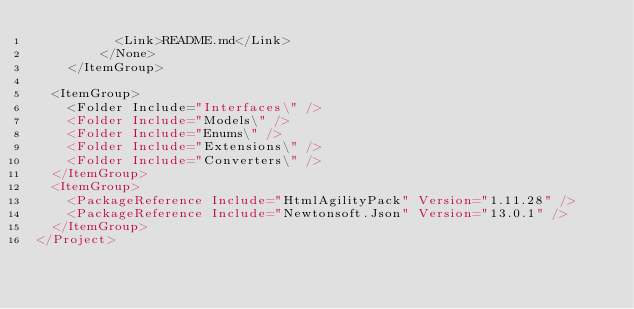<code> <loc_0><loc_0><loc_500><loc_500><_XML_>          <Link>README.md</Link>
        </None>
    </ItemGroup>
  
  <ItemGroup>
    <Folder Include="Interfaces\" />
    <Folder Include="Models\" />
    <Folder Include="Enums\" />
    <Folder Include="Extensions\" />
    <Folder Include="Converters\" />
  </ItemGroup>
  <ItemGroup>
    <PackageReference Include="HtmlAgilityPack" Version="1.11.28" />
    <PackageReference Include="Newtonsoft.Json" Version="13.0.1" />
  </ItemGroup>
</Project>
</code> 